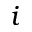<formula> <loc_0><loc_0><loc_500><loc_500>i</formula> 